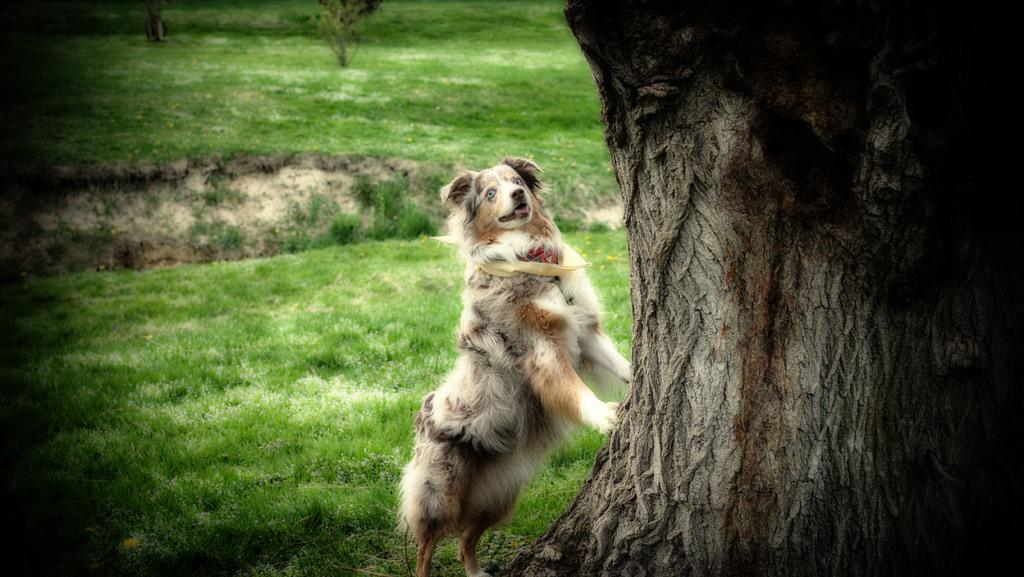What animal is present in the image? There is a dog in the image. What is the dog attempting to do in the image? The dog is trying to climb a tree. What type of vegetation is visible in the image? There is grass in the image. What type of jam can be seen on the tree in the image? There is no jam present in the image; it features a dog trying to climb a tree. What type of sail can be seen on the dog in the image? There is no sail present in the image; the dog is simply trying to climb a tree. 